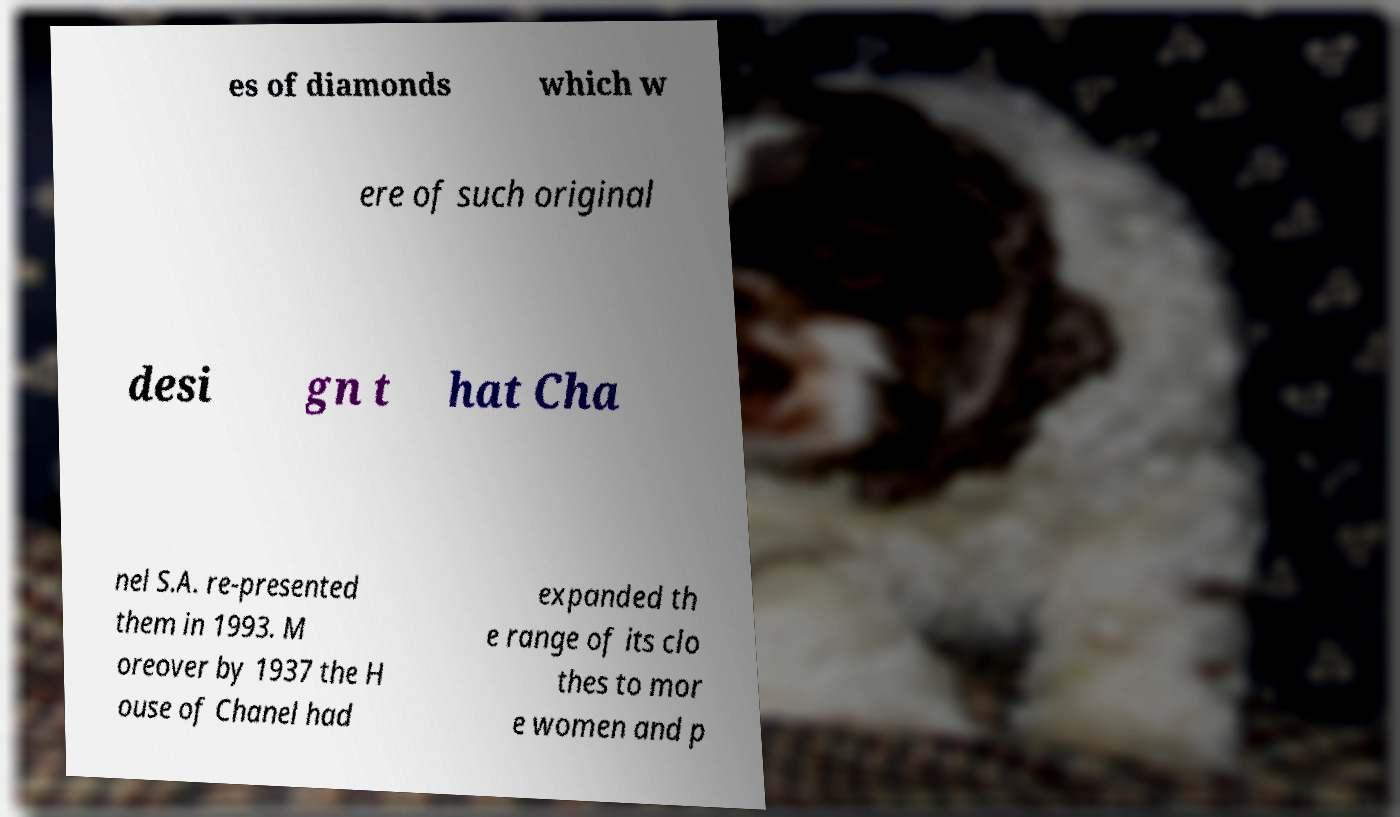For documentation purposes, I need the text within this image transcribed. Could you provide that? es of diamonds which w ere of such original desi gn t hat Cha nel S.A. re-presented them in 1993. M oreover by 1937 the H ouse of Chanel had expanded th e range of its clo thes to mor e women and p 